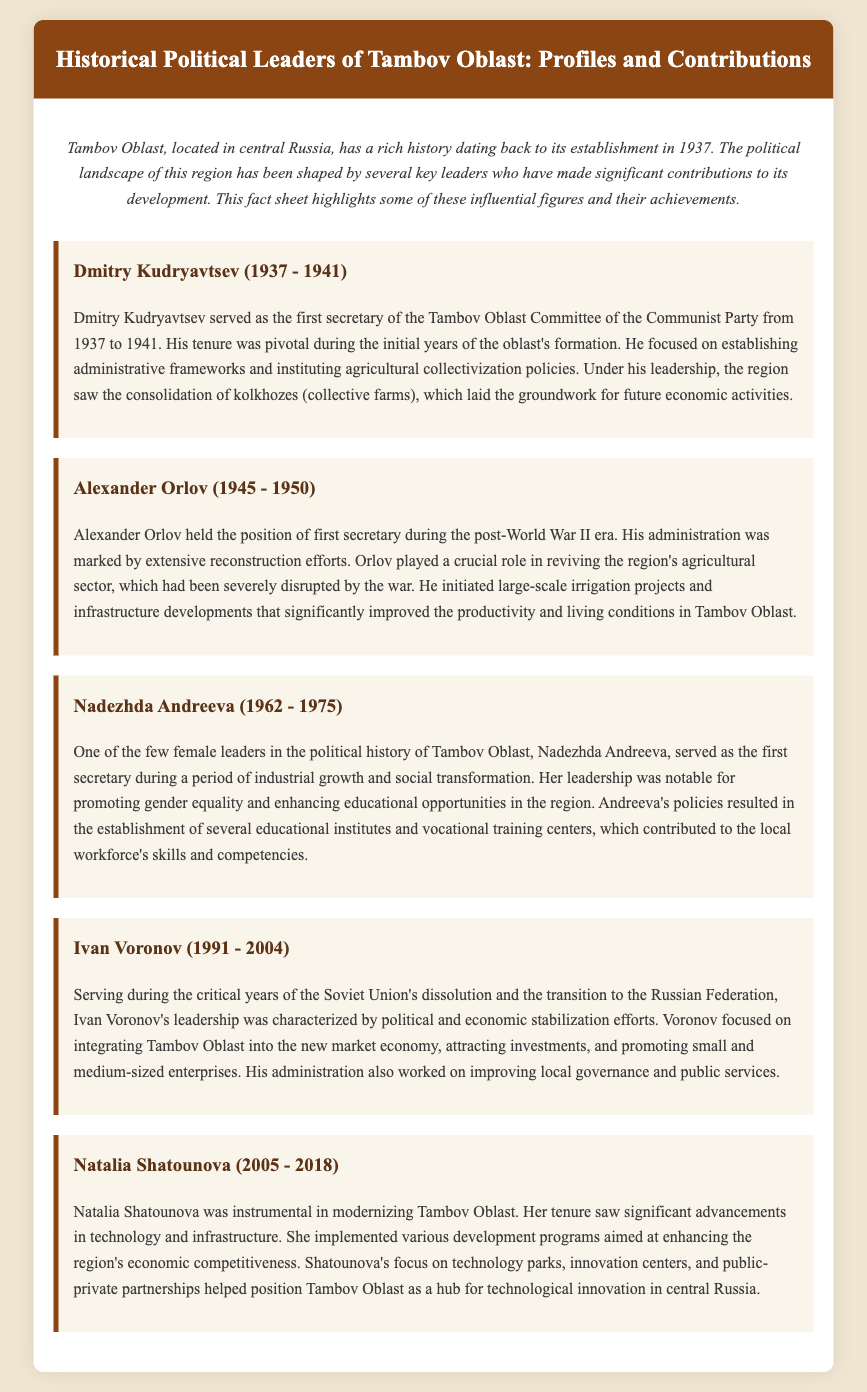What years did Dmitry Kudryavtsev serve as the first secretary? The document specifies that Dmitry Kudryavtsev served from 1937 to 1941.
Answer: 1937 - 1941 Who succeeded Alexander Orlov as first secretary? The document does not specify his direct successor. Therefore, it's not answerable based on the given information.
Answer: Not specified What agricultural policy did Dmitry Kudryavtsev focus on? The document states that he instituted agricultural collectivization policies.
Answer: Agricultural collectivization In what year did Natalia Shatounova's tenure end? The document mentions that her term ended in 2018.
Answer: 2018 What major event characterized Ivan Voronov's leadership? The document notes that it was during the dissolution of the Soviet Union.
Answer: Dissolution of the Soviet Union How many years did Nadezhda Andreeva serve as first secretary? Nadezhda Andreeva served from 1962 to 1975, which totals 13 years.
Answer: 13 years Which leader promoted gender equality? The document highlights Nadezhda Andreeva's promotion of gender equality.
Answer: Nadezhda Andreeva What was a significant focus of Shatounova's modernization efforts? The document indicates that she focused on enhancing technology and infrastructure.
Answer: Technology and infrastructure What type of political system was Ivan Voronov trying to integrate Tambov Oblast into? The document specifies he was integrating into the new market economy.
Answer: New market economy 